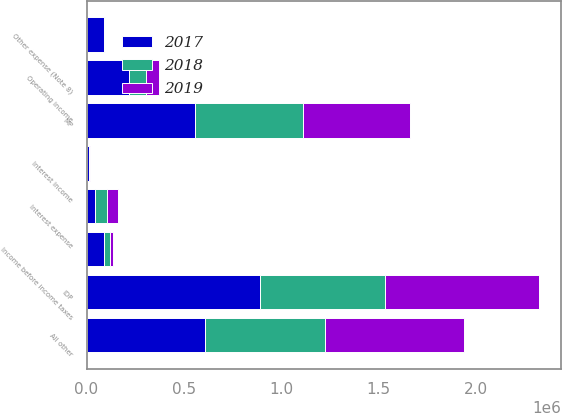Convert chart to OTSL. <chart><loc_0><loc_0><loc_500><loc_500><stacked_bar_chart><ecel><fcel>IDP<fcel>MP<fcel>All other<fcel>Operating income<fcel>Interest expense<fcel>Interest income<fcel>Other expense (Note 8)<fcel>Income before income taxes<nl><fcel>2017<fcel>892665<fcel>558990<fcel>609828<fcel>216466<fcel>43963<fcel>10971<fcel>91682<fcel>91792<nl><fcel>2019<fcel>788495<fcel>549574<fcel>715011<fcel>70282<fcel>59548<fcel>7017<fcel>606<fcel>17145<nl><fcel>2018<fcel>644653<fcel>554001<fcel>618481<fcel>88059<fcel>58879<fcel>1212<fcel>3087<fcel>27305<nl></chart> 